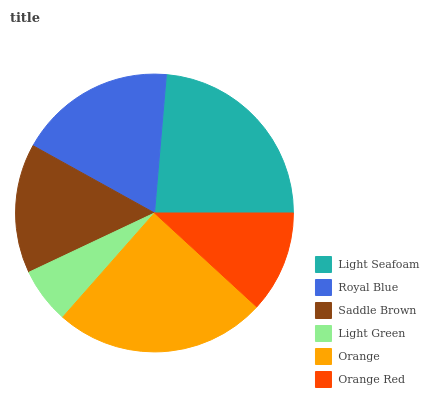Is Light Green the minimum?
Answer yes or no. Yes. Is Orange the maximum?
Answer yes or no. Yes. Is Royal Blue the minimum?
Answer yes or no. No. Is Royal Blue the maximum?
Answer yes or no. No. Is Light Seafoam greater than Royal Blue?
Answer yes or no. Yes. Is Royal Blue less than Light Seafoam?
Answer yes or no. Yes. Is Royal Blue greater than Light Seafoam?
Answer yes or no. No. Is Light Seafoam less than Royal Blue?
Answer yes or no. No. Is Royal Blue the high median?
Answer yes or no. Yes. Is Saddle Brown the low median?
Answer yes or no. Yes. Is Orange the high median?
Answer yes or no. No. Is Light Green the low median?
Answer yes or no. No. 